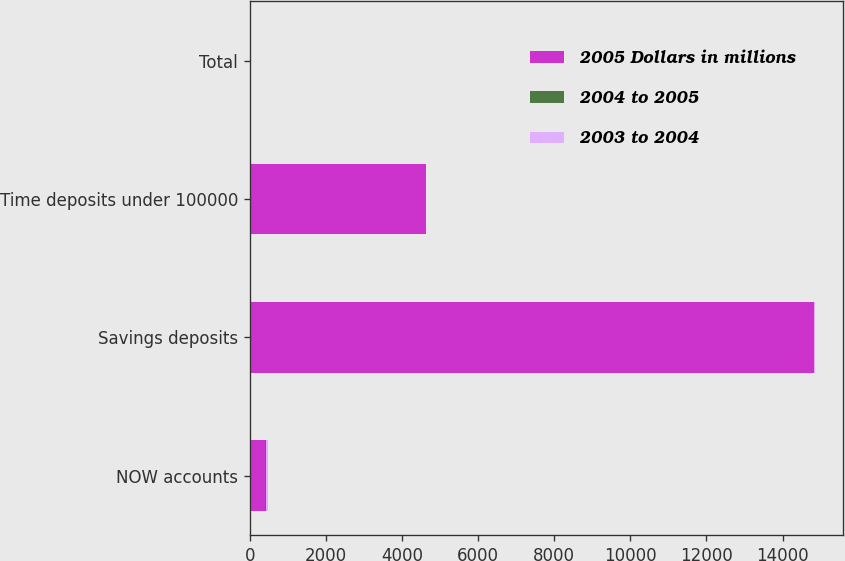<chart> <loc_0><loc_0><loc_500><loc_500><stacked_bar_chart><ecel><fcel>NOW accounts<fcel>Savings deposits<fcel>Time deposits under 100000<fcel>Total<nl><fcel>2005 Dollars in millions<fcel>400<fcel>14827<fcel>4624<fcel>15<nl><fcel>2004 to 2005<fcel>27<fcel>3<fcel>8<fcel>1<nl><fcel>2003 to 2004<fcel>46<fcel>15<fcel>10<fcel>9<nl></chart> 